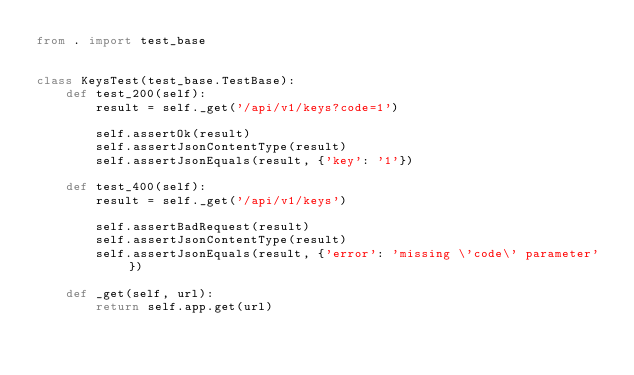Convert code to text. <code><loc_0><loc_0><loc_500><loc_500><_Python_>from . import test_base


class KeysTest(test_base.TestBase):
    def test_200(self):
        result = self._get('/api/v1/keys?code=1')

        self.assertOk(result)
        self.assertJsonContentType(result)
        self.assertJsonEquals(result, {'key': '1'})

    def test_400(self):
        result = self._get('/api/v1/keys')

        self.assertBadRequest(result)
        self.assertJsonContentType(result)
        self.assertJsonEquals(result, {'error': 'missing \'code\' parameter'})

    def _get(self, url):
        return self.app.get(url)
</code> 